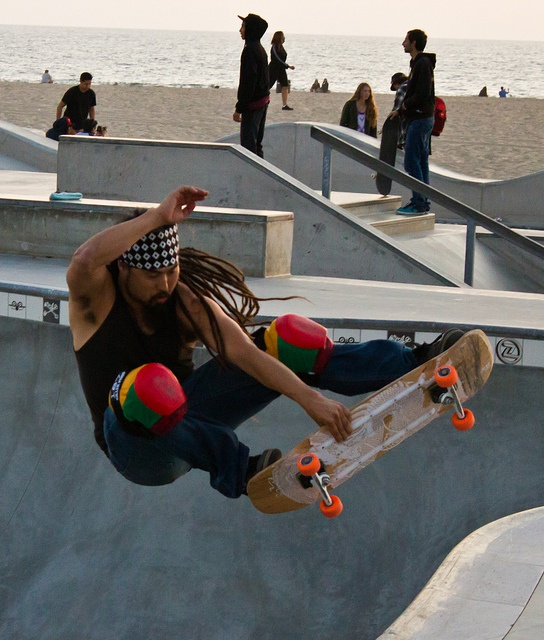Describe the objects in this image and their specific colors. I can see people in white, black, maroon, and gray tones, skateboard in white, gray, and maroon tones, people in white, black, lightgray, maroon, and gray tones, people in white, black, gray, ivory, and darkgray tones, and people in white, black, maroon, and gray tones in this image. 